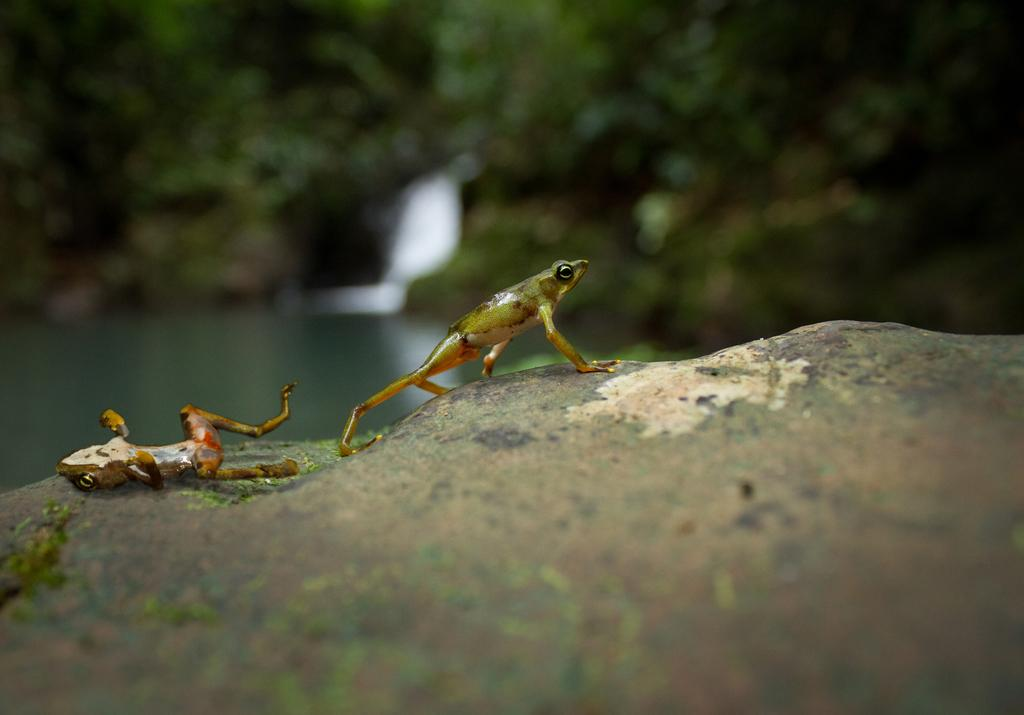How many frogs are present in the image? There are two frogs in the image. What color are the frogs? The frogs are green in color. What can be seen in the background of the image? There is water and trees visible in the background of the image. What is the color of the trees? The trees are green in color. What type of apparel is the frog wearing in the image? There is no apparel visible on the frogs in the image; they are not wearing any clothing. 